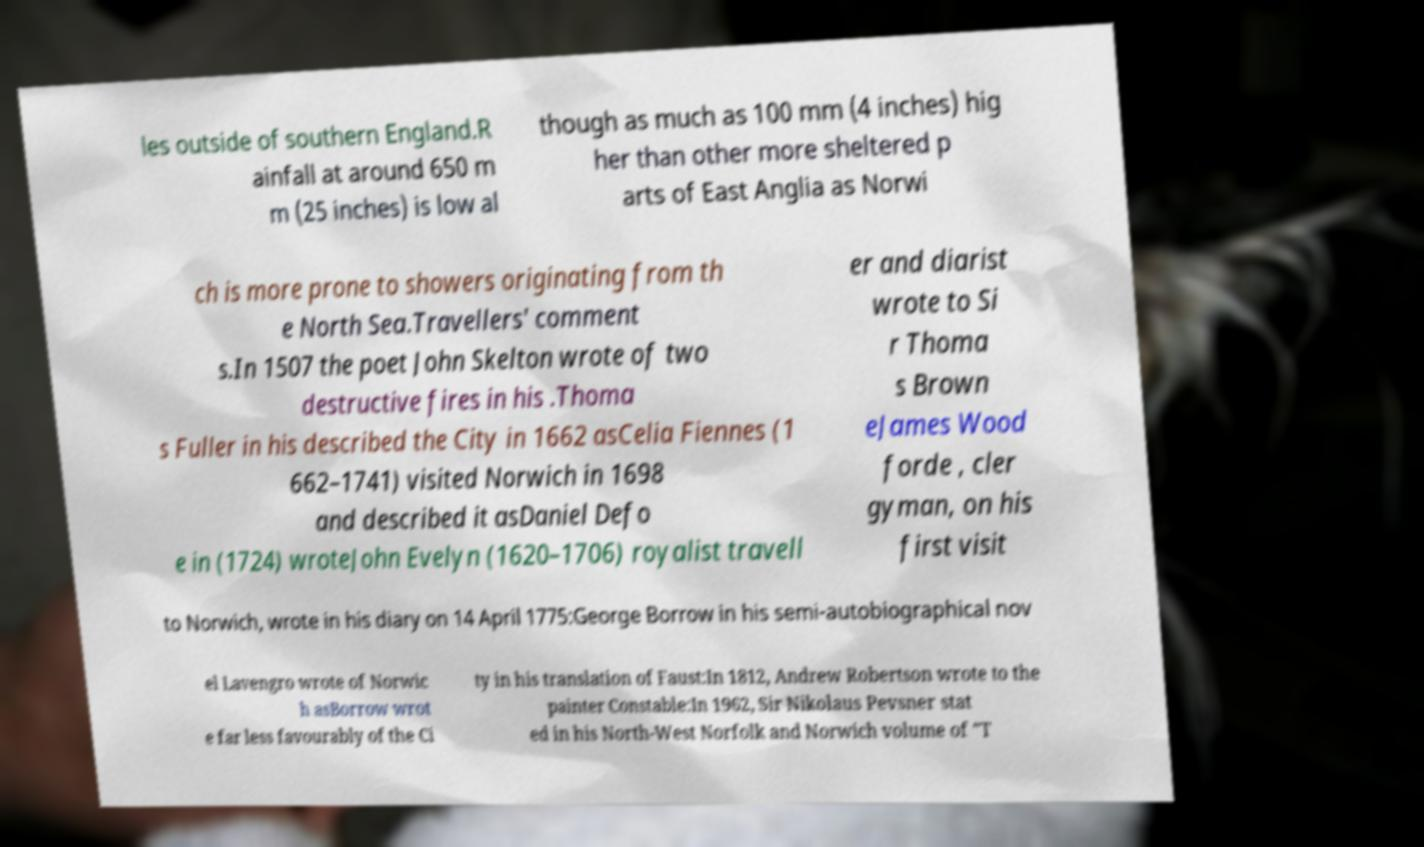There's text embedded in this image that I need extracted. Can you transcribe it verbatim? les outside of southern England.R ainfall at around 650 m m (25 inches) is low al though as much as 100 mm (4 inches) hig her than other more sheltered p arts of East Anglia as Norwi ch is more prone to showers originating from th e North Sea.Travellers' comment s.In 1507 the poet John Skelton wrote of two destructive fires in his .Thoma s Fuller in his described the City in 1662 asCelia Fiennes (1 662–1741) visited Norwich in 1698 and described it asDaniel Defo e in (1724) wroteJohn Evelyn (1620–1706) royalist travell er and diarist wrote to Si r Thoma s Brown eJames Wood forde , cler gyman, on his first visit to Norwich, wrote in his diary on 14 April 1775:George Borrow in his semi-autobiographical nov el Lavengro wrote of Norwic h asBorrow wrot e far less favourably of the Ci ty in his translation of Faust:In 1812, Andrew Robertson wrote to the painter Constable:In 1962, Sir Nikolaus Pevsner stat ed in his North-West Norfolk and Norwich volume of "T 